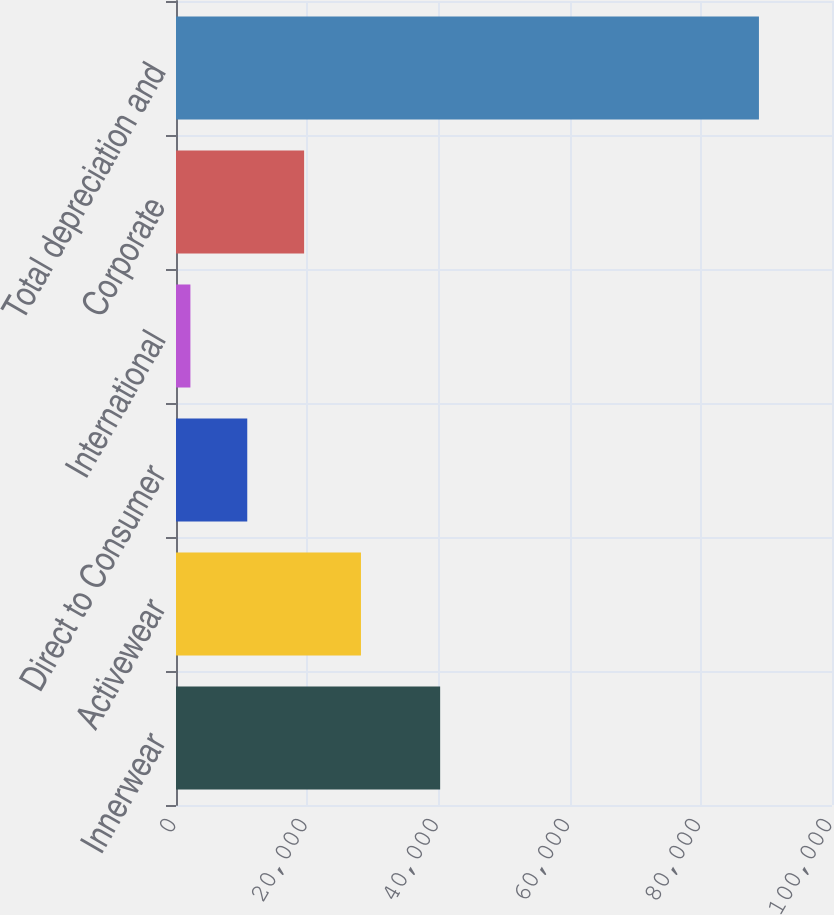Convert chart. <chart><loc_0><loc_0><loc_500><loc_500><bar_chart><fcel>Innerwear<fcel>Activewear<fcel>Direct to Consumer<fcel>International<fcel>Corporate<fcel>Total depreciation and<nl><fcel>40266<fcel>28196.1<fcel>10862.7<fcel>2196<fcel>19529.4<fcel>88863<nl></chart> 